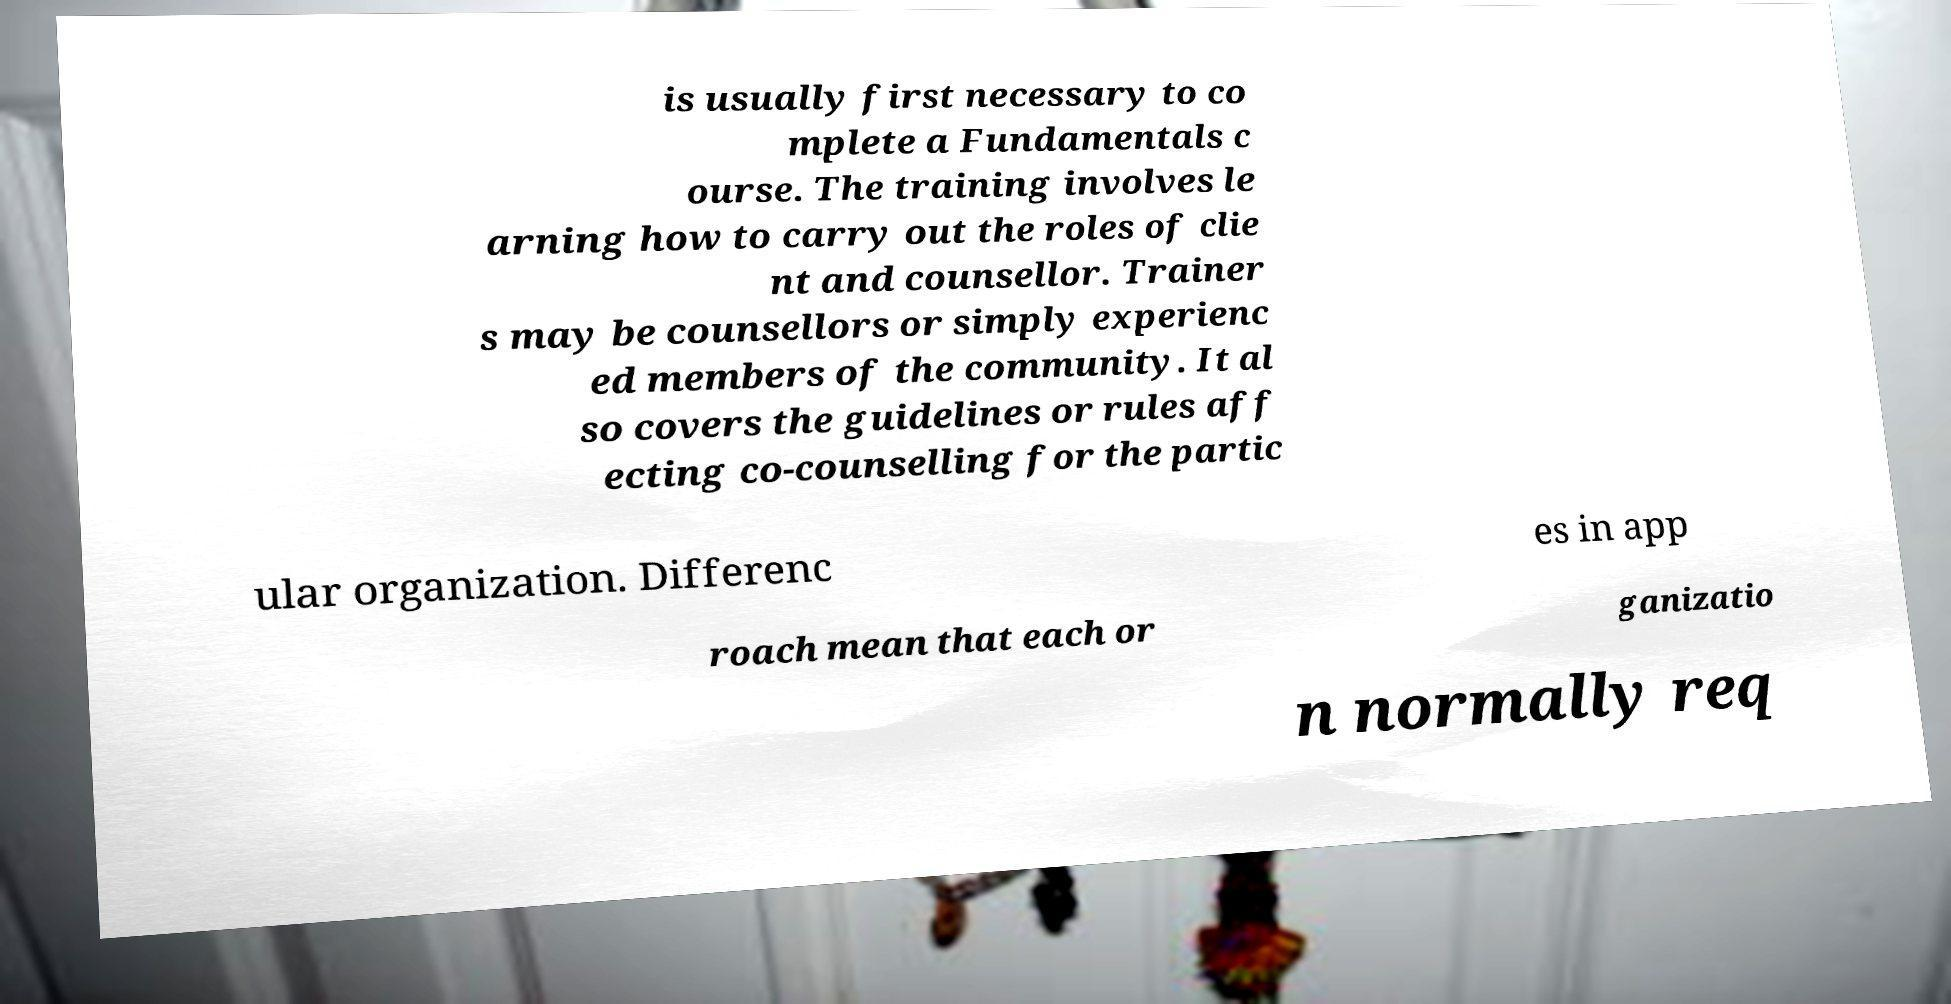What messages or text are displayed in this image? I need them in a readable, typed format. is usually first necessary to co mplete a Fundamentals c ourse. The training involves le arning how to carry out the roles of clie nt and counsellor. Trainer s may be counsellors or simply experienc ed members of the community. It al so covers the guidelines or rules aff ecting co-counselling for the partic ular organization. Differenc es in app roach mean that each or ganizatio n normally req 